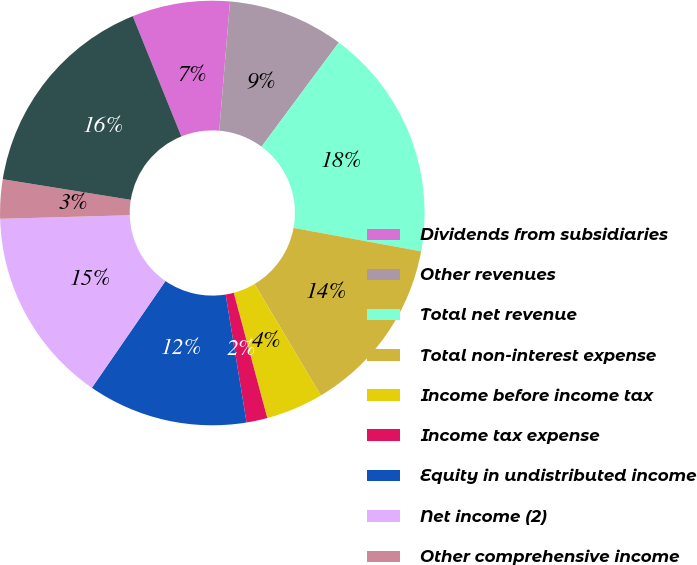<chart> <loc_0><loc_0><loc_500><loc_500><pie_chart><fcel>Dividends from subsidiaries<fcel>Other revenues<fcel>Total net revenue<fcel>Total non-interest expense<fcel>Income before income tax<fcel>Income tax expense<fcel>Equity in undistributed income<fcel>Net income (2)<fcel>Other comprehensive income<fcel>Comprehensive income<nl><fcel>7.44%<fcel>8.83%<fcel>17.73%<fcel>13.57%<fcel>4.37%<fcel>1.59%<fcel>12.18%<fcel>14.96%<fcel>2.98%<fcel>16.34%<nl></chart> 